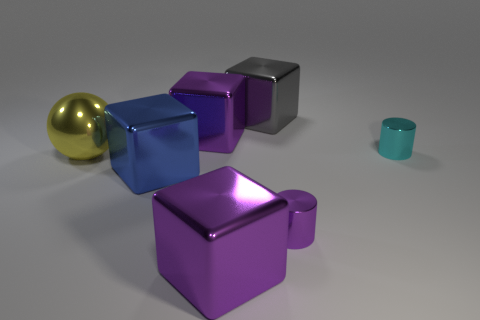Subtract all purple blocks. How many were subtracted if there are1purple blocks left? 1 Subtract 1 cubes. How many cubes are left? 3 Add 2 gray cubes. How many objects exist? 9 Subtract all cylinders. How many objects are left? 5 Subtract all tiny cylinders. Subtract all large things. How many objects are left? 0 Add 1 metallic cubes. How many metallic cubes are left? 5 Add 2 small purple cylinders. How many small purple cylinders exist? 3 Subtract 0 green cylinders. How many objects are left? 7 